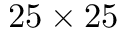Convert formula to latex. <formula><loc_0><loc_0><loc_500><loc_500>2 5 \times 2 5</formula> 